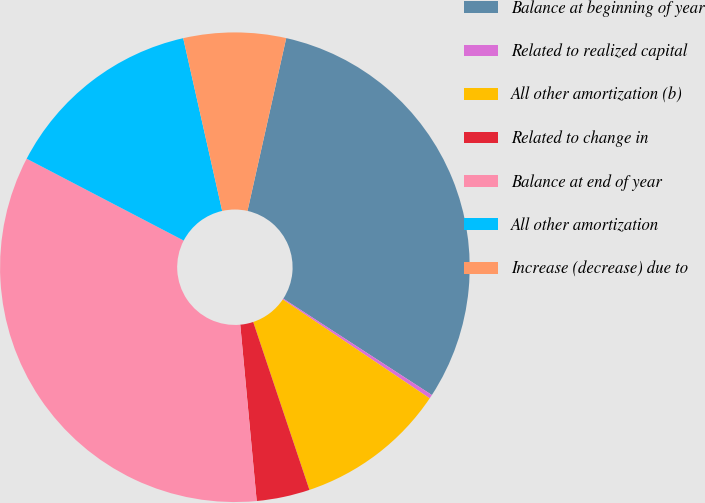Convert chart. <chart><loc_0><loc_0><loc_500><loc_500><pie_chart><fcel>Balance at beginning of year<fcel>Related to realized capital<fcel>All other amortization (b)<fcel>Related to change in<fcel>Balance at end of year<fcel>All other amortization<fcel>Increase (decrease) due to<nl><fcel>30.65%<fcel>0.27%<fcel>10.43%<fcel>3.66%<fcel>34.13%<fcel>13.82%<fcel>7.04%<nl></chart> 